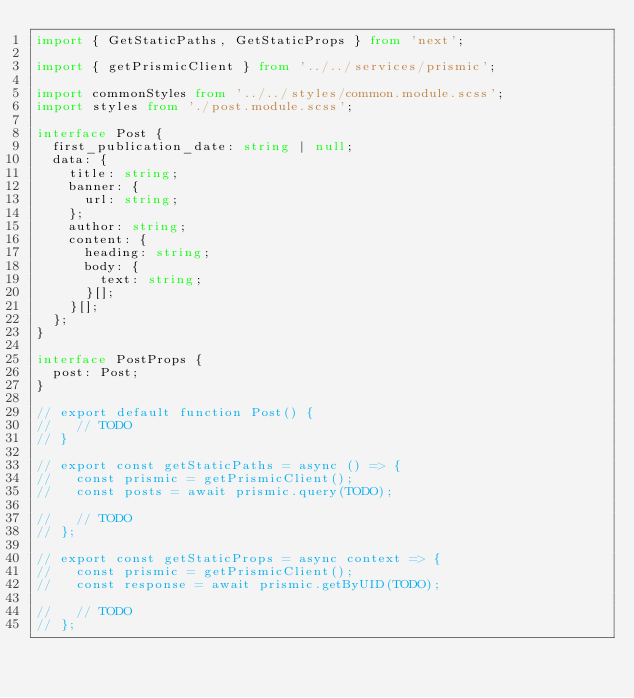<code> <loc_0><loc_0><loc_500><loc_500><_TypeScript_>import { GetStaticPaths, GetStaticProps } from 'next';

import { getPrismicClient } from '../../services/prismic';

import commonStyles from '../../styles/common.module.scss';
import styles from './post.module.scss';

interface Post {
  first_publication_date: string | null;
  data: {
    title: string;
    banner: {
      url: string;
    };
    author: string;
    content: {
      heading: string;
      body: {
        text: string;
      }[];
    }[];
  };
}

interface PostProps {
  post: Post;
}

// export default function Post() {
//   // TODO
// }

// export const getStaticPaths = async () => {
//   const prismic = getPrismicClient();
//   const posts = await prismic.query(TODO);

//   // TODO
// };

// export const getStaticProps = async context => {
//   const prismic = getPrismicClient();
//   const response = await prismic.getByUID(TODO);

//   // TODO
// };
</code> 